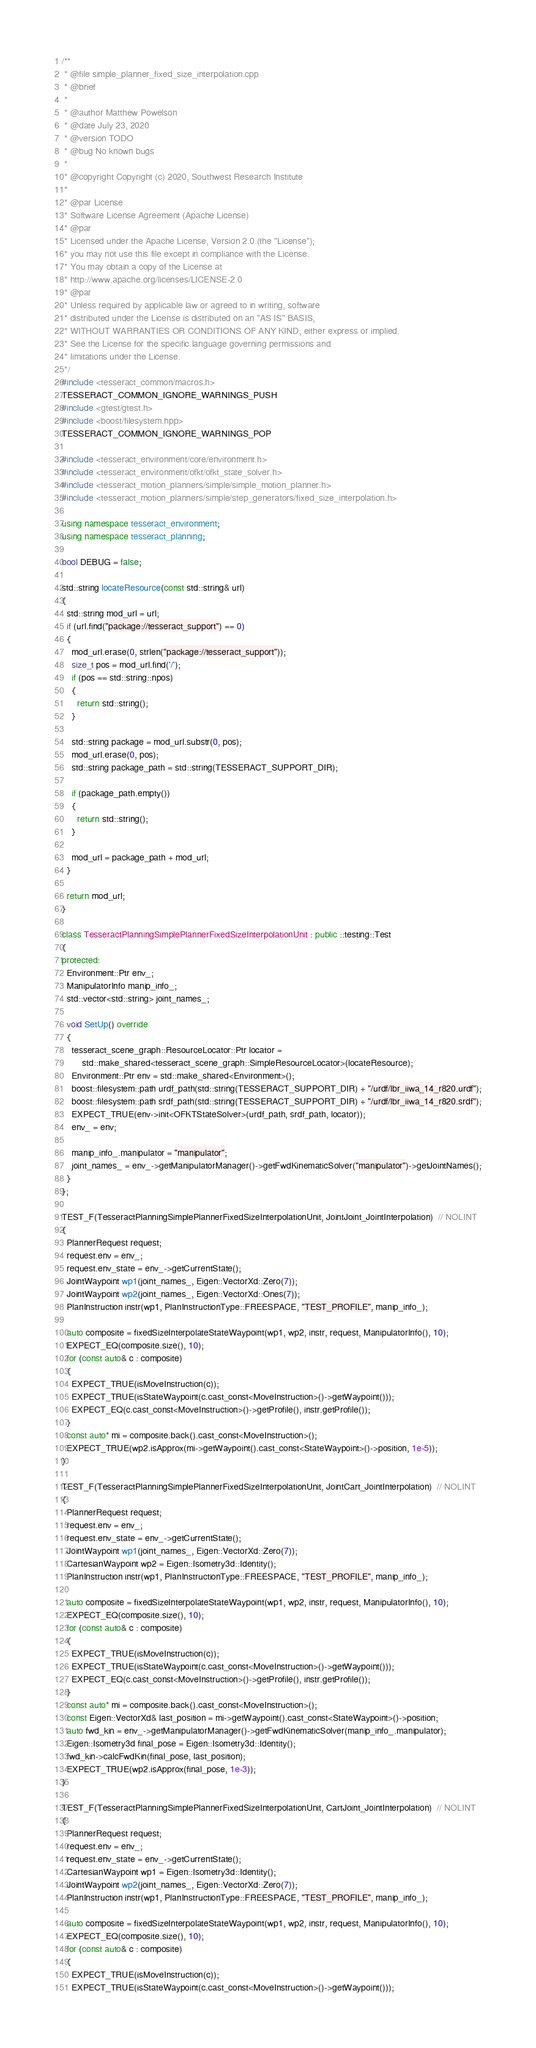Convert code to text. <code><loc_0><loc_0><loc_500><loc_500><_C++_>/**
 * @file simple_planner_fixed_size_interpolation.cpp
 * @brief
 *
 * @author Matthew Powelson
 * @date July 23, 2020
 * @version TODO
 * @bug No known bugs
 *
 * @copyright Copyright (c) 2020, Southwest Research Institute
 *
 * @par License
 * Software License Agreement (Apache License)
 * @par
 * Licensed under the Apache License, Version 2.0 (the "License");
 * you may not use this file except in compliance with the License.
 * You may obtain a copy of the License at
 * http://www.apache.org/licenses/LICENSE-2.0
 * @par
 * Unless required by applicable law or agreed to in writing, software
 * distributed under the License is distributed on an "AS IS" BASIS,
 * WITHOUT WARRANTIES OR CONDITIONS OF ANY KIND, either express or implied.
 * See the License for the specific language governing permissions and
 * limitations under the License.
 */
#include <tesseract_common/macros.h>
TESSERACT_COMMON_IGNORE_WARNINGS_PUSH
#include <gtest/gtest.h>
#include <boost/filesystem.hpp>
TESSERACT_COMMON_IGNORE_WARNINGS_POP

#include <tesseract_environment/core/environment.h>
#include <tesseract_environment/ofkt/ofkt_state_solver.h>
#include <tesseract_motion_planners/simple/simple_motion_planner.h>
#include <tesseract_motion_planners/simple/step_generators/fixed_size_interpolation.h>

using namespace tesseract_environment;
using namespace tesseract_planning;

bool DEBUG = false;

std::string locateResource(const std::string& url)
{
  std::string mod_url = url;
  if (url.find("package://tesseract_support") == 0)
  {
    mod_url.erase(0, strlen("package://tesseract_support"));
    size_t pos = mod_url.find('/');
    if (pos == std::string::npos)
    {
      return std::string();
    }

    std::string package = mod_url.substr(0, pos);
    mod_url.erase(0, pos);
    std::string package_path = std::string(TESSERACT_SUPPORT_DIR);

    if (package_path.empty())
    {
      return std::string();
    }

    mod_url = package_path + mod_url;
  }

  return mod_url;
}

class TesseractPlanningSimplePlannerFixedSizeInterpolationUnit : public ::testing::Test
{
protected:
  Environment::Ptr env_;
  ManipulatorInfo manip_info_;
  std::vector<std::string> joint_names_;

  void SetUp() override
  {
    tesseract_scene_graph::ResourceLocator::Ptr locator =
        std::make_shared<tesseract_scene_graph::SimpleResourceLocator>(locateResource);
    Environment::Ptr env = std::make_shared<Environment>();
    boost::filesystem::path urdf_path(std::string(TESSERACT_SUPPORT_DIR) + "/urdf/lbr_iiwa_14_r820.urdf");
    boost::filesystem::path srdf_path(std::string(TESSERACT_SUPPORT_DIR) + "/urdf/lbr_iiwa_14_r820.srdf");
    EXPECT_TRUE(env->init<OFKTStateSolver>(urdf_path, srdf_path, locator));
    env_ = env;

    manip_info_.manipulator = "manipulator";
    joint_names_ = env_->getManipulatorManager()->getFwdKinematicSolver("manipulator")->getJointNames();
  }
};

TEST_F(TesseractPlanningSimplePlannerFixedSizeInterpolationUnit, JointJoint_JointInterpolation)  // NOLINT
{
  PlannerRequest request;
  request.env = env_;
  request.env_state = env_->getCurrentState();
  JointWaypoint wp1(joint_names_, Eigen::VectorXd::Zero(7));
  JointWaypoint wp2(joint_names_, Eigen::VectorXd::Ones(7));
  PlanInstruction instr(wp1, PlanInstructionType::FREESPACE, "TEST_PROFILE", manip_info_);

  auto composite = fixedSizeInterpolateStateWaypoint(wp1, wp2, instr, request, ManipulatorInfo(), 10);
  EXPECT_EQ(composite.size(), 10);
  for (const auto& c : composite)
  {
    EXPECT_TRUE(isMoveInstruction(c));
    EXPECT_TRUE(isStateWaypoint(c.cast_const<MoveInstruction>()->getWaypoint()));
    EXPECT_EQ(c.cast_const<MoveInstruction>()->getProfile(), instr.getProfile());
  }
  const auto* mi = composite.back().cast_const<MoveInstruction>();
  EXPECT_TRUE(wp2.isApprox(mi->getWaypoint().cast_const<StateWaypoint>()->position, 1e-5));
}

TEST_F(TesseractPlanningSimplePlannerFixedSizeInterpolationUnit, JointCart_JointInterpolation)  // NOLINT
{
  PlannerRequest request;
  request.env = env_;
  request.env_state = env_->getCurrentState();
  JointWaypoint wp1(joint_names_, Eigen::VectorXd::Zero(7));
  CartesianWaypoint wp2 = Eigen::Isometry3d::Identity();
  PlanInstruction instr(wp1, PlanInstructionType::FREESPACE, "TEST_PROFILE", manip_info_);

  auto composite = fixedSizeInterpolateStateWaypoint(wp1, wp2, instr, request, ManipulatorInfo(), 10);
  EXPECT_EQ(composite.size(), 10);
  for (const auto& c : composite)
  {
    EXPECT_TRUE(isMoveInstruction(c));
    EXPECT_TRUE(isStateWaypoint(c.cast_const<MoveInstruction>()->getWaypoint()));
    EXPECT_EQ(c.cast_const<MoveInstruction>()->getProfile(), instr.getProfile());
  }
  const auto* mi = composite.back().cast_const<MoveInstruction>();
  const Eigen::VectorXd& last_position = mi->getWaypoint().cast_const<StateWaypoint>()->position;
  auto fwd_kin = env_->getManipulatorManager()->getFwdKinematicSolver(manip_info_.manipulator);
  Eigen::Isometry3d final_pose = Eigen::Isometry3d::Identity();
  fwd_kin->calcFwdKin(final_pose, last_position);
  EXPECT_TRUE(wp2.isApprox(final_pose, 1e-3));
}

TEST_F(TesseractPlanningSimplePlannerFixedSizeInterpolationUnit, CartJoint_JointInterpolation)  // NOLINT
{
  PlannerRequest request;
  request.env = env_;
  request.env_state = env_->getCurrentState();
  CartesianWaypoint wp1 = Eigen::Isometry3d::Identity();
  JointWaypoint wp2(joint_names_, Eigen::VectorXd::Zero(7));
  PlanInstruction instr(wp1, PlanInstructionType::FREESPACE, "TEST_PROFILE", manip_info_);

  auto composite = fixedSizeInterpolateStateWaypoint(wp1, wp2, instr, request, ManipulatorInfo(), 10);
  EXPECT_EQ(composite.size(), 10);
  for (const auto& c : composite)
  {
    EXPECT_TRUE(isMoveInstruction(c));
    EXPECT_TRUE(isStateWaypoint(c.cast_const<MoveInstruction>()->getWaypoint()));</code> 